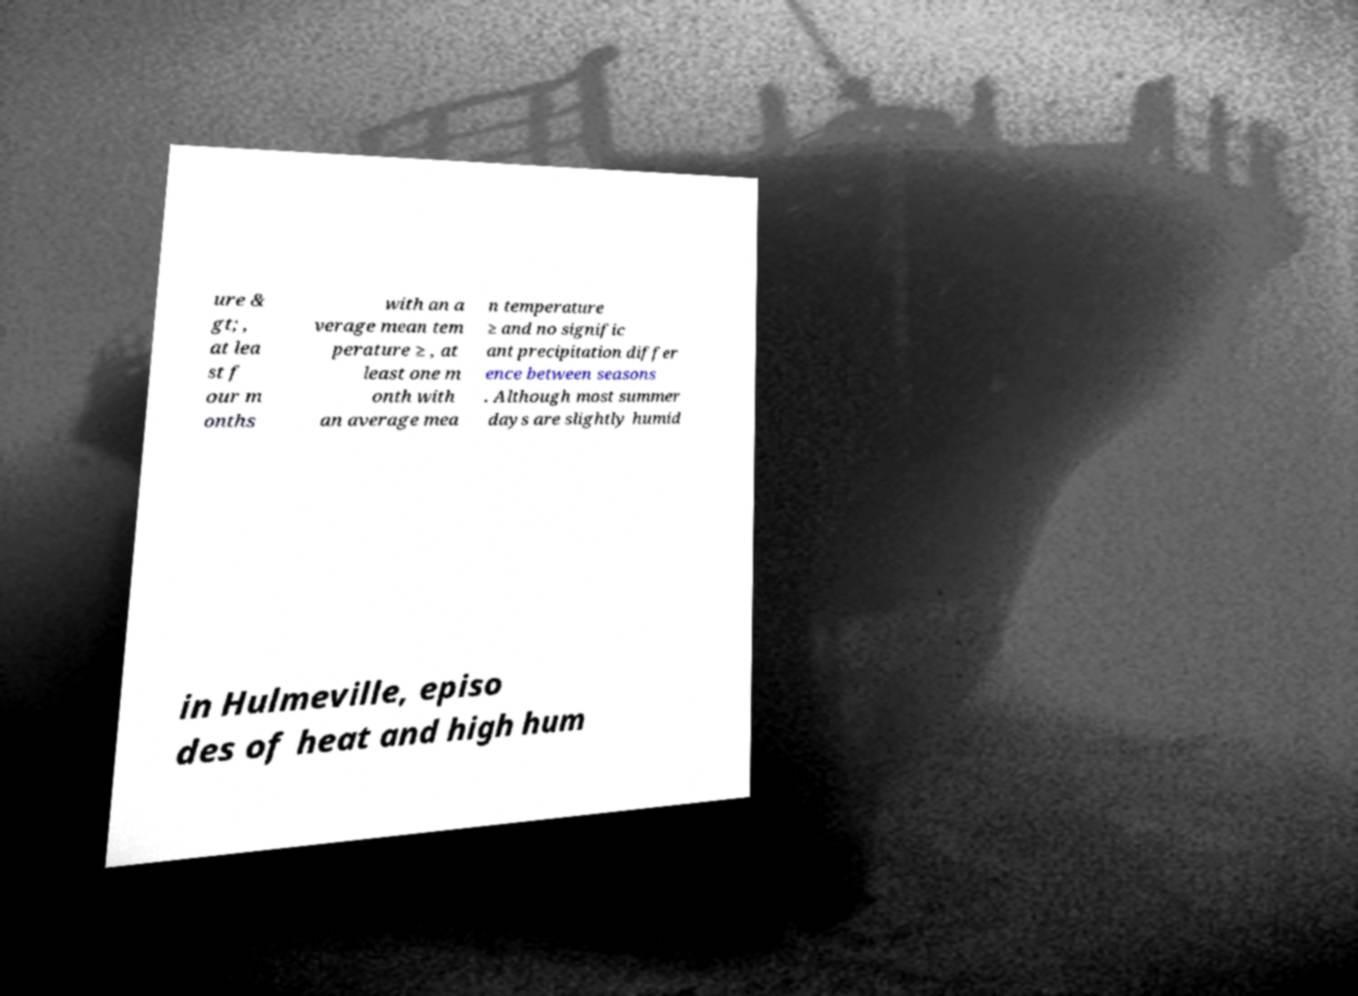Can you accurately transcribe the text from the provided image for me? ure & gt; , at lea st f our m onths with an a verage mean tem perature ≥ , at least one m onth with an average mea n temperature ≥ and no signific ant precipitation differ ence between seasons . Although most summer days are slightly humid in Hulmeville, episo des of heat and high hum 